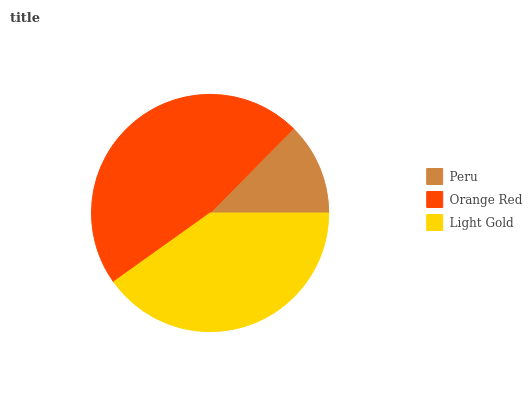Is Peru the minimum?
Answer yes or no. Yes. Is Orange Red the maximum?
Answer yes or no. Yes. Is Light Gold the minimum?
Answer yes or no. No. Is Light Gold the maximum?
Answer yes or no. No. Is Orange Red greater than Light Gold?
Answer yes or no. Yes. Is Light Gold less than Orange Red?
Answer yes or no. Yes. Is Light Gold greater than Orange Red?
Answer yes or no. No. Is Orange Red less than Light Gold?
Answer yes or no. No. Is Light Gold the high median?
Answer yes or no. Yes. Is Light Gold the low median?
Answer yes or no. Yes. Is Orange Red the high median?
Answer yes or no. No. Is Peru the low median?
Answer yes or no. No. 